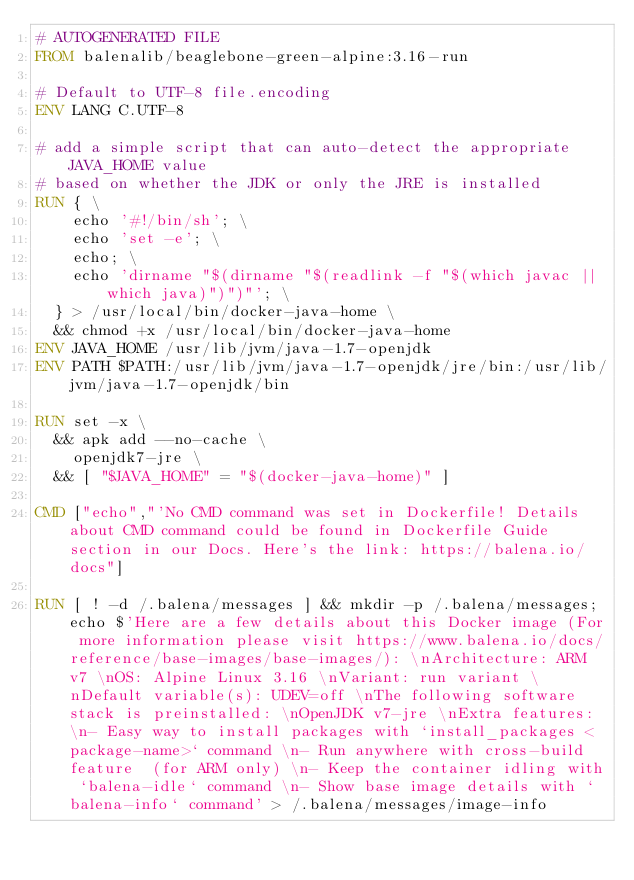Convert code to text. <code><loc_0><loc_0><loc_500><loc_500><_Dockerfile_># AUTOGENERATED FILE
FROM balenalib/beaglebone-green-alpine:3.16-run

# Default to UTF-8 file.encoding
ENV LANG C.UTF-8

# add a simple script that can auto-detect the appropriate JAVA_HOME value
# based on whether the JDK or only the JRE is installed
RUN { \
		echo '#!/bin/sh'; \
		echo 'set -e'; \
		echo; \
		echo 'dirname "$(dirname "$(readlink -f "$(which javac || which java)")")"'; \
	} > /usr/local/bin/docker-java-home \
	&& chmod +x /usr/local/bin/docker-java-home
ENV JAVA_HOME /usr/lib/jvm/java-1.7-openjdk
ENV PATH $PATH:/usr/lib/jvm/java-1.7-openjdk/jre/bin:/usr/lib/jvm/java-1.7-openjdk/bin

RUN set -x \
	&& apk add --no-cache \
		openjdk7-jre \
	&& [ "$JAVA_HOME" = "$(docker-java-home)" ]

CMD ["echo","'No CMD command was set in Dockerfile! Details about CMD command could be found in Dockerfile Guide section in our Docs. Here's the link: https://balena.io/docs"]

RUN [ ! -d /.balena/messages ] && mkdir -p /.balena/messages; echo $'Here are a few details about this Docker image (For more information please visit https://www.balena.io/docs/reference/base-images/base-images/): \nArchitecture: ARM v7 \nOS: Alpine Linux 3.16 \nVariant: run variant \nDefault variable(s): UDEV=off \nThe following software stack is preinstalled: \nOpenJDK v7-jre \nExtra features: \n- Easy way to install packages with `install_packages <package-name>` command \n- Run anywhere with cross-build feature  (for ARM only) \n- Keep the container idling with `balena-idle` command \n- Show base image details with `balena-info` command' > /.balena/messages/image-info</code> 